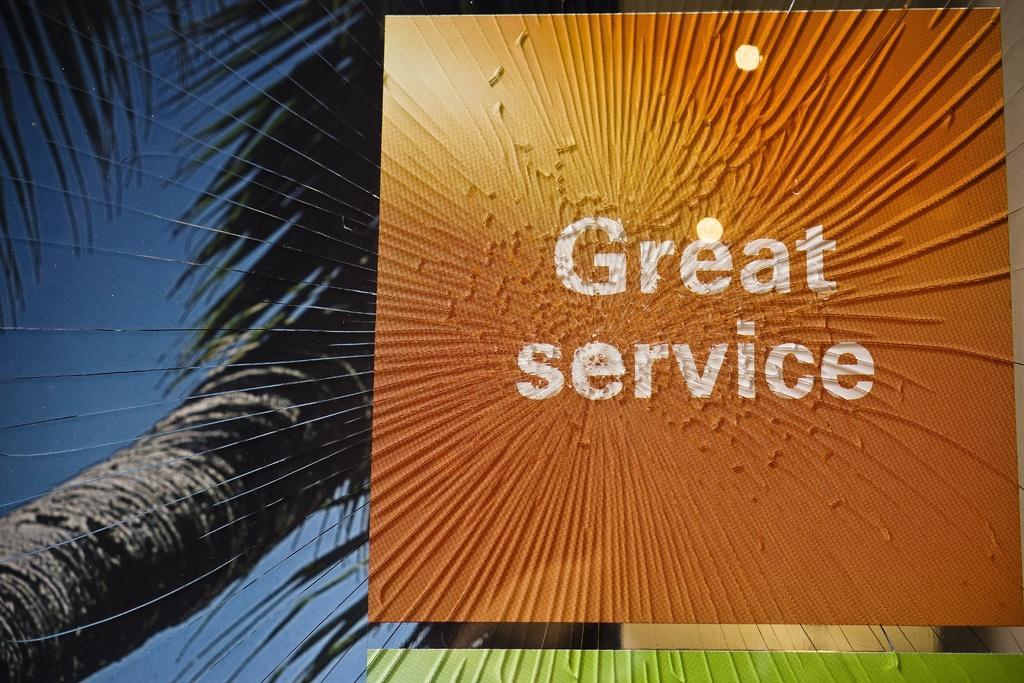How would you summarize this image in a sentence or two? This is a poster and in the foreground of this poster, there is an orange box and text written on it as "GREAT SERVICE". In the background, there is a tree and the sky. 